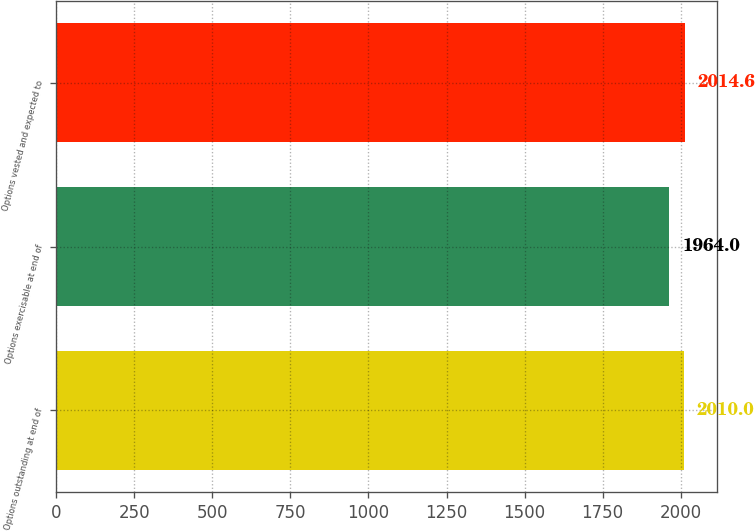<chart> <loc_0><loc_0><loc_500><loc_500><bar_chart><fcel>Options outstanding at end of<fcel>Options exercisable at end of<fcel>Options vested and expected to<nl><fcel>2010<fcel>1964<fcel>2014.6<nl></chart> 